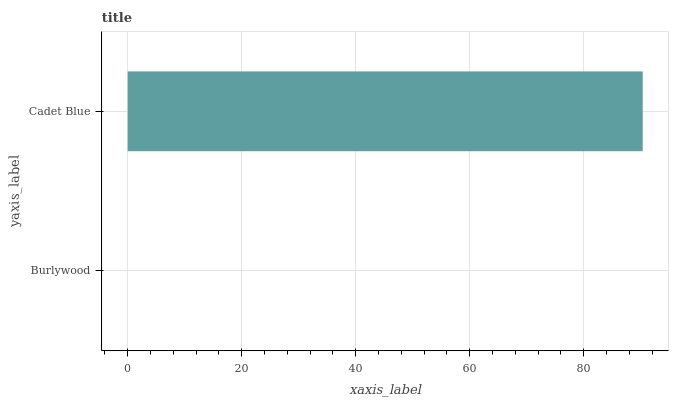Is Burlywood the minimum?
Answer yes or no. Yes. Is Cadet Blue the maximum?
Answer yes or no. Yes. Is Cadet Blue the minimum?
Answer yes or no. No. Is Cadet Blue greater than Burlywood?
Answer yes or no. Yes. Is Burlywood less than Cadet Blue?
Answer yes or no. Yes. Is Burlywood greater than Cadet Blue?
Answer yes or no. No. Is Cadet Blue less than Burlywood?
Answer yes or no. No. Is Cadet Blue the high median?
Answer yes or no. Yes. Is Burlywood the low median?
Answer yes or no. Yes. Is Burlywood the high median?
Answer yes or no. No. Is Cadet Blue the low median?
Answer yes or no. No. 